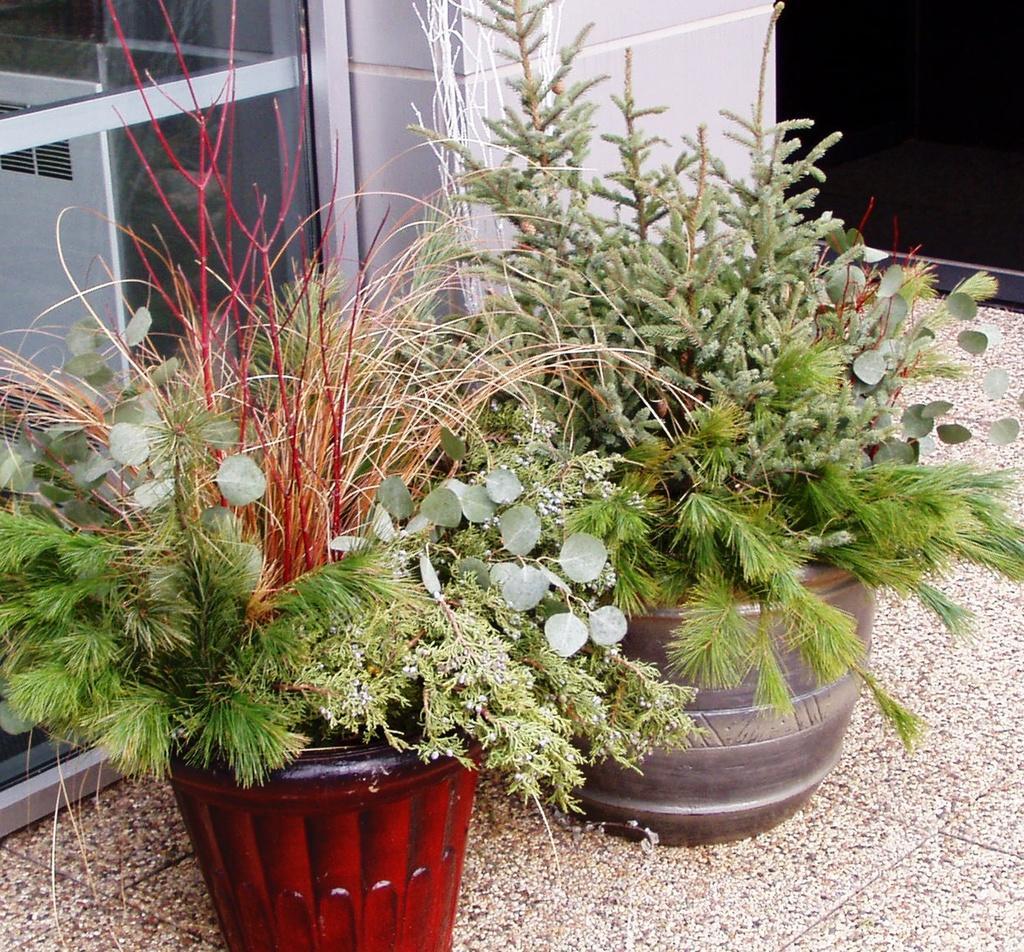Can you describe this image briefly? Here we can see planets on the floor. In the background we can see glass and wall. 